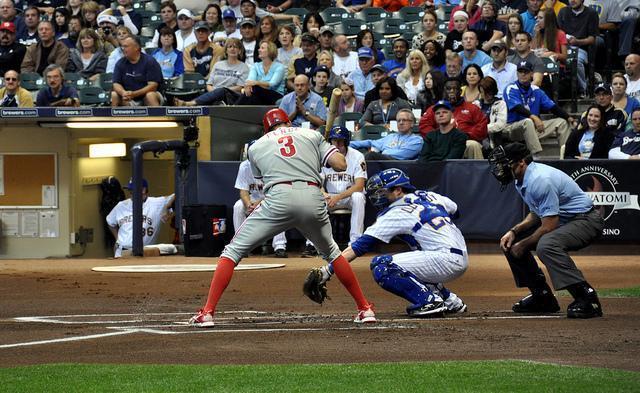How many people are in the photo?
Give a very brief answer. 5. 